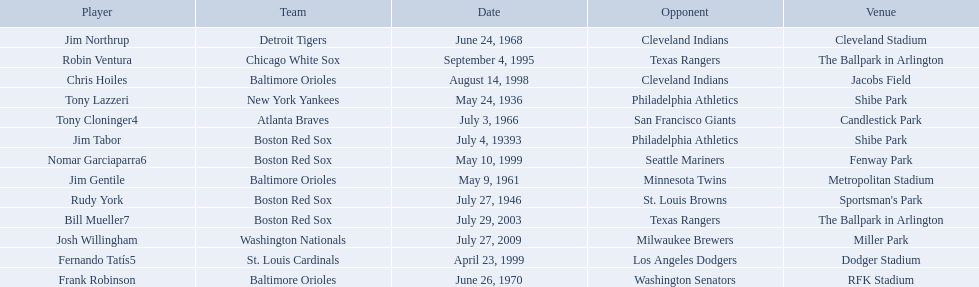Could you help me parse every detail presented in this table? {'header': ['Player', 'Team', 'Date', 'Opponent', 'Venue'], 'rows': [['Jim Northrup', 'Detroit Tigers', 'June 24, 1968', 'Cleveland Indians', 'Cleveland Stadium'], ['Robin Ventura', 'Chicago White Sox', 'September 4, 1995', 'Texas Rangers', 'The Ballpark in Arlington'], ['Chris Hoiles', 'Baltimore Orioles', 'August 14, 1998', 'Cleveland Indians', 'Jacobs Field'], ['Tony Lazzeri', 'New York Yankees', 'May 24, 1936', 'Philadelphia Athletics', 'Shibe Park'], ['Tony Cloninger4', 'Atlanta Braves', 'July 3, 1966', 'San Francisco Giants', 'Candlestick Park'], ['Jim Tabor', 'Boston Red Sox', 'July 4, 19393', 'Philadelphia Athletics', 'Shibe Park'], ['Nomar Garciaparra6', 'Boston Red Sox', 'May 10, 1999', 'Seattle Mariners', 'Fenway Park'], ['Jim Gentile', 'Baltimore Orioles', 'May 9, 1961', 'Minnesota Twins', 'Metropolitan Stadium'], ['Rudy York', 'Boston Red Sox', 'July 27, 1946', 'St. Louis Browns', "Sportsman's Park"], ['Bill Mueller7', 'Boston Red Sox', 'July 29, 2003', 'Texas Rangers', 'The Ballpark in Arlington'], ['Josh Willingham', 'Washington Nationals', 'July 27, 2009', 'Milwaukee Brewers', 'Miller Park'], ['Fernando Tatís5', 'St. Louis Cardinals', 'April 23, 1999', 'Los Angeles Dodgers', 'Dodger Stadium'], ['Frank Robinson', 'Baltimore Orioles', 'June 26, 1970', 'Washington Senators', 'RFK Stadium']]} Which teams played between the years 1960 and 1970? Baltimore Orioles, Atlanta Braves, Detroit Tigers, Baltimore Orioles. Of these teams that played, which ones played against the cleveland indians? Detroit Tigers. On what day did these two teams play? June 24, 1968. 